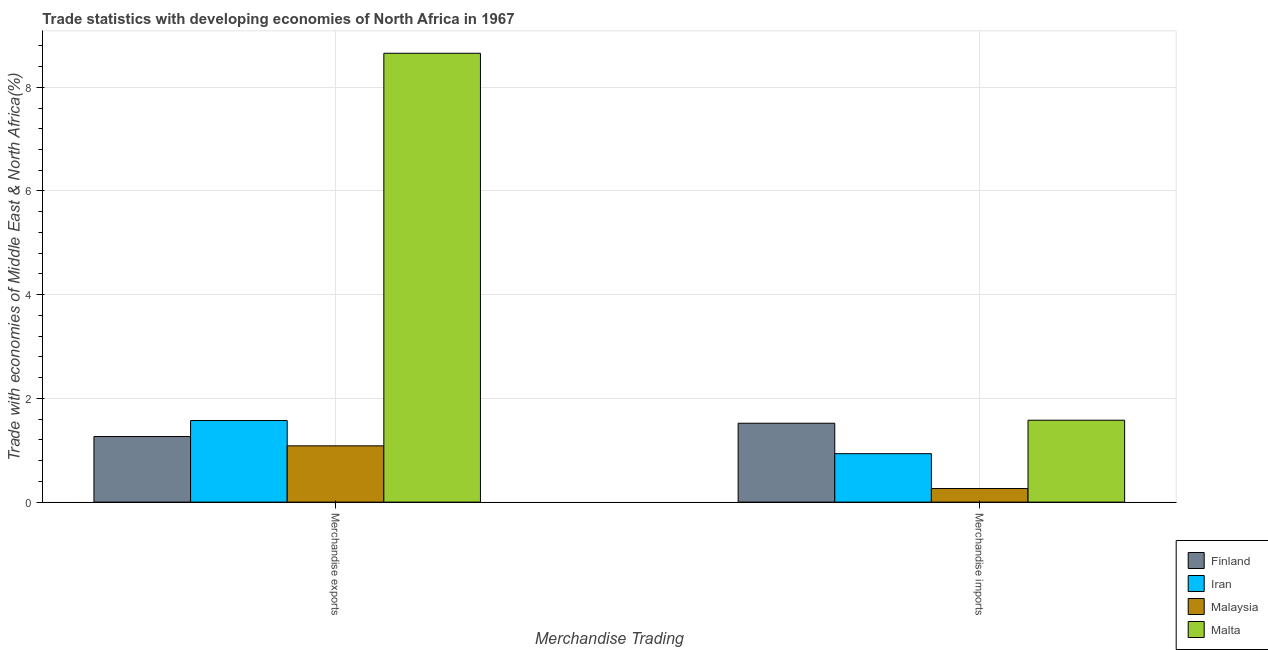How many groups of bars are there?
Your answer should be very brief. 2. Are the number of bars per tick equal to the number of legend labels?
Ensure brevity in your answer.  Yes. Are the number of bars on each tick of the X-axis equal?
Make the answer very short. Yes. How many bars are there on the 1st tick from the left?
Make the answer very short. 4. What is the label of the 2nd group of bars from the left?
Offer a terse response. Merchandise imports. What is the merchandise imports in Malta?
Ensure brevity in your answer.  1.58. Across all countries, what is the maximum merchandise imports?
Make the answer very short. 1.58. Across all countries, what is the minimum merchandise exports?
Keep it short and to the point. 1.09. In which country was the merchandise exports maximum?
Offer a terse response. Malta. In which country was the merchandise exports minimum?
Offer a very short reply. Malaysia. What is the total merchandise exports in the graph?
Offer a terse response. 12.58. What is the difference between the merchandise imports in Finland and that in Malaysia?
Your response must be concise. 1.26. What is the difference between the merchandise exports in Finland and the merchandise imports in Malaysia?
Your response must be concise. 1. What is the average merchandise exports per country?
Your answer should be compact. 3.14. What is the difference between the merchandise imports and merchandise exports in Malta?
Ensure brevity in your answer.  -7.08. What is the ratio of the merchandise exports in Iran to that in Malaysia?
Your answer should be very brief. 1.45. In how many countries, is the merchandise imports greater than the average merchandise imports taken over all countries?
Offer a very short reply. 2. What does the 2nd bar from the left in Merchandise imports represents?
Provide a short and direct response. Iran. How many bars are there?
Provide a succinct answer. 8. Are all the bars in the graph horizontal?
Offer a terse response. No. Does the graph contain any zero values?
Your response must be concise. No. Does the graph contain grids?
Offer a very short reply. Yes. Where does the legend appear in the graph?
Your response must be concise. Bottom right. What is the title of the graph?
Offer a terse response. Trade statistics with developing economies of North Africa in 1967. Does "Cambodia" appear as one of the legend labels in the graph?
Offer a terse response. No. What is the label or title of the X-axis?
Your answer should be very brief. Merchandise Trading. What is the label or title of the Y-axis?
Provide a short and direct response. Trade with economies of Middle East & North Africa(%). What is the Trade with economies of Middle East & North Africa(%) in Finland in Merchandise exports?
Ensure brevity in your answer.  1.26. What is the Trade with economies of Middle East & North Africa(%) in Iran in Merchandise exports?
Make the answer very short. 1.57. What is the Trade with economies of Middle East & North Africa(%) of Malaysia in Merchandise exports?
Give a very brief answer. 1.09. What is the Trade with economies of Middle East & North Africa(%) in Malta in Merchandise exports?
Offer a very short reply. 8.66. What is the Trade with economies of Middle East & North Africa(%) of Finland in Merchandise imports?
Provide a succinct answer. 1.52. What is the Trade with economies of Middle East & North Africa(%) in Iran in Merchandise imports?
Your response must be concise. 0.93. What is the Trade with economies of Middle East & North Africa(%) in Malaysia in Merchandise imports?
Give a very brief answer. 0.26. What is the Trade with economies of Middle East & North Africa(%) in Malta in Merchandise imports?
Ensure brevity in your answer.  1.58. Across all Merchandise Trading, what is the maximum Trade with economies of Middle East & North Africa(%) in Finland?
Offer a very short reply. 1.52. Across all Merchandise Trading, what is the maximum Trade with economies of Middle East & North Africa(%) of Iran?
Keep it short and to the point. 1.57. Across all Merchandise Trading, what is the maximum Trade with economies of Middle East & North Africa(%) of Malaysia?
Offer a very short reply. 1.09. Across all Merchandise Trading, what is the maximum Trade with economies of Middle East & North Africa(%) of Malta?
Keep it short and to the point. 8.66. Across all Merchandise Trading, what is the minimum Trade with economies of Middle East & North Africa(%) of Finland?
Offer a very short reply. 1.26. Across all Merchandise Trading, what is the minimum Trade with economies of Middle East & North Africa(%) in Iran?
Make the answer very short. 0.93. Across all Merchandise Trading, what is the minimum Trade with economies of Middle East & North Africa(%) in Malaysia?
Provide a short and direct response. 0.26. Across all Merchandise Trading, what is the minimum Trade with economies of Middle East & North Africa(%) in Malta?
Your answer should be very brief. 1.58. What is the total Trade with economies of Middle East & North Africa(%) in Finland in the graph?
Provide a succinct answer. 2.79. What is the total Trade with economies of Middle East & North Africa(%) in Iran in the graph?
Provide a succinct answer. 2.51. What is the total Trade with economies of Middle East & North Africa(%) of Malaysia in the graph?
Your answer should be very brief. 1.35. What is the total Trade with economies of Middle East & North Africa(%) in Malta in the graph?
Offer a terse response. 10.24. What is the difference between the Trade with economies of Middle East & North Africa(%) of Finland in Merchandise exports and that in Merchandise imports?
Offer a very short reply. -0.26. What is the difference between the Trade with economies of Middle East & North Africa(%) in Iran in Merchandise exports and that in Merchandise imports?
Offer a terse response. 0.64. What is the difference between the Trade with economies of Middle East & North Africa(%) in Malaysia in Merchandise exports and that in Merchandise imports?
Your response must be concise. 0.82. What is the difference between the Trade with economies of Middle East & North Africa(%) in Malta in Merchandise exports and that in Merchandise imports?
Provide a succinct answer. 7.08. What is the difference between the Trade with economies of Middle East & North Africa(%) in Finland in Merchandise exports and the Trade with economies of Middle East & North Africa(%) in Iran in Merchandise imports?
Offer a terse response. 0.33. What is the difference between the Trade with economies of Middle East & North Africa(%) of Finland in Merchandise exports and the Trade with economies of Middle East & North Africa(%) of Malta in Merchandise imports?
Ensure brevity in your answer.  -0.31. What is the difference between the Trade with economies of Middle East & North Africa(%) of Iran in Merchandise exports and the Trade with economies of Middle East & North Africa(%) of Malaysia in Merchandise imports?
Make the answer very short. 1.31. What is the difference between the Trade with economies of Middle East & North Africa(%) in Iran in Merchandise exports and the Trade with economies of Middle East & North Africa(%) in Malta in Merchandise imports?
Keep it short and to the point. -0.01. What is the difference between the Trade with economies of Middle East & North Africa(%) of Malaysia in Merchandise exports and the Trade with economies of Middle East & North Africa(%) of Malta in Merchandise imports?
Your answer should be compact. -0.49. What is the average Trade with economies of Middle East & North Africa(%) in Finland per Merchandise Trading?
Provide a succinct answer. 1.39. What is the average Trade with economies of Middle East & North Africa(%) in Iran per Merchandise Trading?
Your answer should be compact. 1.25. What is the average Trade with economies of Middle East & North Africa(%) of Malaysia per Merchandise Trading?
Offer a very short reply. 0.67. What is the average Trade with economies of Middle East & North Africa(%) of Malta per Merchandise Trading?
Ensure brevity in your answer.  5.12. What is the difference between the Trade with economies of Middle East & North Africa(%) in Finland and Trade with economies of Middle East & North Africa(%) in Iran in Merchandise exports?
Give a very brief answer. -0.31. What is the difference between the Trade with economies of Middle East & North Africa(%) of Finland and Trade with economies of Middle East & North Africa(%) of Malaysia in Merchandise exports?
Provide a short and direct response. 0.18. What is the difference between the Trade with economies of Middle East & North Africa(%) in Finland and Trade with economies of Middle East & North Africa(%) in Malta in Merchandise exports?
Provide a short and direct response. -7.39. What is the difference between the Trade with economies of Middle East & North Africa(%) in Iran and Trade with economies of Middle East & North Africa(%) in Malaysia in Merchandise exports?
Your answer should be compact. 0.49. What is the difference between the Trade with economies of Middle East & North Africa(%) of Iran and Trade with economies of Middle East & North Africa(%) of Malta in Merchandise exports?
Your answer should be compact. -7.08. What is the difference between the Trade with economies of Middle East & North Africa(%) in Malaysia and Trade with economies of Middle East & North Africa(%) in Malta in Merchandise exports?
Provide a succinct answer. -7.57. What is the difference between the Trade with economies of Middle East & North Africa(%) in Finland and Trade with economies of Middle East & North Africa(%) in Iran in Merchandise imports?
Keep it short and to the point. 0.59. What is the difference between the Trade with economies of Middle East & North Africa(%) of Finland and Trade with economies of Middle East & North Africa(%) of Malaysia in Merchandise imports?
Ensure brevity in your answer.  1.26. What is the difference between the Trade with economies of Middle East & North Africa(%) in Finland and Trade with economies of Middle East & North Africa(%) in Malta in Merchandise imports?
Offer a terse response. -0.06. What is the difference between the Trade with economies of Middle East & North Africa(%) of Iran and Trade with economies of Middle East & North Africa(%) of Malaysia in Merchandise imports?
Offer a terse response. 0.67. What is the difference between the Trade with economies of Middle East & North Africa(%) in Iran and Trade with economies of Middle East & North Africa(%) in Malta in Merchandise imports?
Keep it short and to the point. -0.65. What is the difference between the Trade with economies of Middle East & North Africa(%) in Malaysia and Trade with economies of Middle East & North Africa(%) in Malta in Merchandise imports?
Your answer should be very brief. -1.32. What is the ratio of the Trade with economies of Middle East & North Africa(%) in Finland in Merchandise exports to that in Merchandise imports?
Give a very brief answer. 0.83. What is the ratio of the Trade with economies of Middle East & North Africa(%) of Iran in Merchandise exports to that in Merchandise imports?
Provide a short and direct response. 1.68. What is the ratio of the Trade with economies of Middle East & North Africa(%) in Malaysia in Merchandise exports to that in Merchandise imports?
Make the answer very short. 4.14. What is the ratio of the Trade with economies of Middle East & North Africa(%) in Malta in Merchandise exports to that in Merchandise imports?
Offer a terse response. 5.48. What is the difference between the highest and the second highest Trade with economies of Middle East & North Africa(%) in Finland?
Ensure brevity in your answer.  0.26. What is the difference between the highest and the second highest Trade with economies of Middle East & North Africa(%) in Iran?
Offer a very short reply. 0.64. What is the difference between the highest and the second highest Trade with economies of Middle East & North Africa(%) of Malaysia?
Give a very brief answer. 0.82. What is the difference between the highest and the second highest Trade with economies of Middle East & North Africa(%) of Malta?
Provide a succinct answer. 7.08. What is the difference between the highest and the lowest Trade with economies of Middle East & North Africa(%) of Finland?
Your answer should be compact. 0.26. What is the difference between the highest and the lowest Trade with economies of Middle East & North Africa(%) of Iran?
Offer a very short reply. 0.64. What is the difference between the highest and the lowest Trade with economies of Middle East & North Africa(%) of Malaysia?
Your answer should be compact. 0.82. What is the difference between the highest and the lowest Trade with economies of Middle East & North Africa(%) in Malta?
Your answer should be compact. 7.08. 